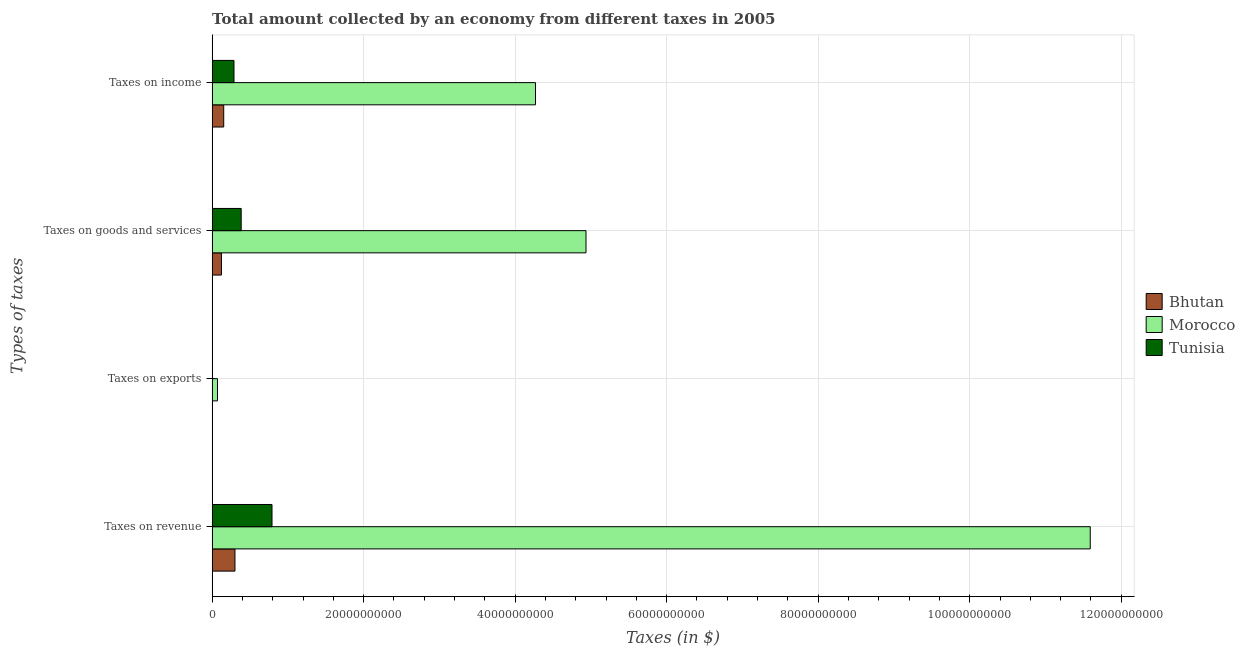How many different coloured bars are there?
Provide a succinct answer. 3. Are the number of bars per tick equal to the number of legend labels?
Your answer should be very brief. Yes. How many bars are there on the 2nd tick from the bottom?
Provide a short and direct response. 3. What is the label of the 1st group of bars from the top?
Provide a short and direct response. Taxes on income. What is the amount collected as tax on exports in Morocco?
Your answer should be compact. 7.10e+08. Across all countries, what is the maximum amount collected as tax on goods?
Keep it short and to the point. 4.94e+1. Across all countries, what is the minimum amount collected as tax on revenue?
Offer a terse response. 3.01e+09. In which country was the amount collected as tax on income maximum?
Make the answer very short. Morocco. In which country was the amount collected as tax on revenue minimum?
Offer a very short reply. Bhutan. What is the total amount collected as tax on income in the graph?
Keep it short and to the point. 4.71e+1. What is the difference between the amount collected as tax on goods in Tunisia and that in Morocco?
Offer a terse response. -4.55e+1. What is the difference between the amount collected as tax on revenue in Morocco and the amount collected as tax on goods in Bhutan?
Your response must be concise. 1.15e+11. What is the average amount collected as tax on goods per country?
Your answer should be compact. 1.81e+1. What is the difference between the amount collected as tax on exports and amount collected as tax on income in Bhutan?
Your response must be concise. -1.53e+09. In how many countries, is the amount collected as tax on exports greater than 28000000000 $?
Make the answer very short. 0. What is the ratio of the amount collected as tax on income in Morocco to that in Tunisia?
Give a very brief answer. 14.79. Is the amount collected as tax on goods in Bhutan less than that in Morocco?
Your answer should be very brief. Yes. What is the difference between the highest and the second highest amount collected as tax on revenue?
Provide a short and direct response. 1.08e+11. What is the difference between the highest and the lowest amount collected as tax on goods?
Your answer should be very brief. 4.81e+1. Is the sum of the amount collected as tax on income in Tunisia and Bhutan greater than the maximum amount collected as tax on revenue across all countries?
Make the answer very short. No. Is it the case that in every country, the sum of the amount collected as tax on exports and amount collected as tax on revenue is greater than the sum of amount collected as tax on goods and amount collected as tax on income?
Offer a very short reply. No. What does the 3rd bar from the top in Taxes on revenue represents?
Provide a succinct answer. Bhutan. What does the 2nd bar from the bottom in Taxes on exports represents?
Keep it short and to the point. Morocco. Are all the bars in the graph horizontal?
Your answer should be compact. Yes. How many countries are there in the graph?
Give a very brief answer. 3. What is the difference between two consecutive major ticks on the X-axis?
Offer a terse response. 2.00e+1. Where does the legend appear in the graph?
Provide a short and direct response. Center right. What is the title of the graph?
Provide a succinct answer. Total amount collected by an economy from different taxes in 2005. What is the label or title of the X-axis?
Provide a succinct answer. Taxes (in $). What is the label or title of the Y-axis?
Your answer should be compact. Types of taxes. What is the Taxes (in $) in Bhutan in Taxes on revenue?
Provide a succinct answer. 3.01e+09. What is the Taxes (in $) in Morocco in Taxes on revenue?
Offer a terse response. 1.16e+11. What is the Taxes (in $) of Tunisia in Taxes on revenue?
Your answer should be very brief. 7.90e+09. What is the Taxes (in $) of Bhutan in Taxes on exports?
Provide a short and direct response. 8.70e+05. What is the Taxes (in $) of Morocco in Taxes on exports?
Make the answer very short. 7.10e+08. What is the Taxes (in $) of Tunisia in Taxes on exports?
Your answer should be very brief. 7.40e+06. What is the Taxes (in $) in Bhutan in Taxes on goods and services?
Offer a terse response. 1.23e+09. What is the Taxes (in $) of Morocco in Taxes on goods and services?
Provide a succinct answer. 4.94e+1. What is the Taxes (in $) in Tunisia in Taxes on goods and services?
Your answer should be very brief. 3.84e+09. What is the Taxes (in $) in Bhutan in Taxes on income?
Your answer should be very brief. 1.53e+09. What is the Taxes (in $) in Morocco in Taxes on income?
Offer a terse response. 4.27e+1. What is the Taxes (in $) of Tunisia in Taxes on income?
Your response must be concise. 2.89e+09. Across all Types of taxes, what is the maximum Taxes (in $) of Bhutan?
Your answer should be very brief. 3.01e+09. Across all Types of taxes, what is the maximum Taxes (in $) of Morocco?
Give a very brief answer. 1.16e+11. Across all Types of taxes, what is the maximum Taxes (in $) in Tunisia?
Provide a succinct answer. 7.90e+09. Across all Types of taxes, what is the minimum Taxes (in $) of Bhutan?
Your response must be concise. 8.70e+05. Across all Types of taxes, what is the minimum Taxes (in $) in Morocco?
Your response must be concise. 7.10e+08. Across all Types of taxes, what is the minimum Taxes (in $) of Tunisia?
Your answer should be compact. 7.40e+06. What is the total Taxes (in $) in Bhutan in the graph?
Provide a succinct answer. 5.78e+09. What is the total Taxes (in $) in Morocco in the graph?
Ensure brevity in your answer.  2.09e+11. What is the total Taxes (in $) in Tunisia in the graph?
Make the answer very short. 1.46e+1. What is the difference between the Taxes (in $) of Bhutan in Taxes on revenue and that in Taxes on exports?
Give a very brief answer. 3.01e+09. What is the difference between the Taxes (in $) in Morocco in Taxes on revenue and that in Taxes on exports?
Your response must be concise. 1.15e+11. What is the difference between the Taxes (in $) of Tunisia in Taxes on revenue and that in Taxes on exports?
Give a very brief answer. 7.90e+09. What is the difference between the Taxes (in $) in Bhutan in Taxes on revenue and that in Taxes on goods and services?
Your answer should be very brief. 1.78e+09. What is the difference between the Taxes (in $) of Morocco in Taxes on revenue and that in Taxes on goods and services?
Provide a short and direct response. 6.66e+1. What is the difference between the Taxes (in $) in Tunisia in Taxes on revenue and that in Taxes on goods and services?
Provide a short and direct response. 4.07e+09. What is the difference between the Taxes (in $) in Bhutan in Taxes on revenue and that in Taxes on income?
Provide a short and direct response. 1.48e+09. What is the difference between the Taxes (in $) in Morocco in Taxes on revenue and that in Taxes on income?
Offer a very short reply. 7.32e+1. What is the difference between the Taxes (in $) of Tunisia in Taxes on revenue and that in Taxes on income?
Offer a terse response. 5.02e+09. What is the difference between the Taxes (in $) of Bhutan in Taxes on exports and that in Taxes on goods and services?
Offer a terse response. -1.23e+09. What is the difference between the Taxes (in $) in Morocco in Taxes on exports and that in Taxes on goods and services?
Provide a succinct answer. -4.86e+1. What is the difference between the Taxes (in $) in Tunisia in Taxes on exports and that in Taxes on goods and services?
Keep it short and to the point. -3.83e+09. What is the difference between the Taxes (in $) of Bhutan in Taxes on exports and that in Taxes on income?
Keep it short and to the point. -1.53e+09. What is the difference between the Taxes (in $) of Morocco in Taxes on exports and that in Taxes on income?
Offer a very short reply. -4.20e+1. What is the difference between the Taxes (in $) of Tunisia in Taxes on exports and that in Taxes on income?
Ensure brevity in your answer.  -2.88e+09. What is the difference between the Taxes (in $) in Bhutan in Taxes on goods and services and that in Taxes on income?
Offer a very short reply. -3.00e+08. What is the difference between the Taxes (in $) of Morocco in Taxes on goods and services and that in Taxes on income?
Offer a very short reply. 6.67e+09. What is the difference between the Taxes (in $) of Tunisia in Taxes on goods and services and that in Taxes on income?
Offer a very short reply. 9.51e+08. What is the difference between the Taxes (in $) in Bhutan in Taxes on revenue and the Taxes (in $) in Morocco in Taxes on exports?
Offer a very short reply. 2.30e+09. What is the difference between the Taxes (in $) of Bhutan in Taxes on revenue and the Taxes (in $) of Tunisia in Taxes on exports?
Provide a succinct answer. 3.01e+09. What is the difference between the Taxes (in $) in Morocco in Taxes on revenue and the Taxes (in $) in Tunisia in Taxes on exports?
Your answer should be compact. 1.16e+11. What is the difference between the Taxes (in $) of Bhutan in Taxes on revenue and the Taxes (in $) of Morocco in Taxes on goods and services?
Provide a short and direct response. -4.63e+1. What is the difference between the Taxes (in $) in Bhutan in Taxes on revenue and the Taxes (in $) in Tunisia in Taxes on goods and services?
Your answer should be compact. -8.23e+08. What is the difference between the Taxes (in $) of Morocco in Taxes on revenue and the Taxes (in $) of Tunisia in Taxes on goods and services?
Make the answer very short. 1.12e+11. What is the difference between the Taxes (in $) of Bhutan in Taxes on revenue and the Taxes (in $) of Morocco in Taxes on income?
Provide a short and direct response. -3.97e+1. What is the difference between the Taxes (in $) in Bhutan in Taxes on revenue and the Taxes (in $) in Tunisia in Taxes on income?
Provide a succinct answer. 1.28e+08. What is the difference between the Taxes (in $) in Morocco in Taxes on revenue and the Taxes (in $) in Tunisia in Taxes on income?
Ensure brevity in your answer.  1.13e+11. What is the difference between the Taxes (in $) of Bhutan in Taxes on exports and the Taxes (in $) of Morocco in Taxes on goods and services?
Offer a very short reply. -4.93e+1. What is the difference between the Taxes (in $) in Bhutan in Taxes on exports and the Taxes (in $) in Tunisia in Taxes on goods and services?
Keep it short and to the point. -3.84e+09. What is the difference between the Taxes (in $) of Morocco in Taxes on exports and the Taxes (in $) of Tunisia in Taxes on goods and services?
Keep it short and to the point. -3.13e+09. What is the difference between the Taxes (in $) of Bhutan in Taxes on exports and the Taxes (in $) of Morocco in Taxes on income?
Provide a succinct answer. -4.27e+1. What is the difference between the Taxes (in $) of Bhutan in Taxes on exports and the Taxes (in $) of Tunisia in Taxes on income?
Offer a very short reply. -2.89e+09. What is the difference between the Taxes (in $) of Morocco in Taxes on exports and the Taxes (in $) of Tunisia in Taxes on income?
Your response must be concise. -2.18e+09. What is the difference between the Taxes (in $) of Bhutan in Taxes on goods and services and the Taxes (in $) of Morocco in Taxes on income?
Make the answer very short. -4.15e+1. What is the difference between the Taxes (in $) of Bhutan in Taxes on goods and services and the Taxes (in $) of Tunisia in Taxes on income?
Provide a succinct answer. -1.66e+09. What is the difference between the Taxes (in $) of Morocco in Taxes on goods and services and the Taxes (in $) of Tunisia in Taxes on income?
Offer a very short reply. 4.65e+1. What is the average Taxes (in $) of Bhutan per Types of taxes?
Give a very brief answer. 1.44e+09. What is the average Taxes (in $) in Morocco per Types of taxes?
Provide a short and direct response. 5.22e+1. What is the average Taxes (in $) of Tunisia per Types of taxes?
Your response must be concise. 3.66e+09. What is the difference between the Taxes (in $) in Bhutan and Taxes (in $) in Morocco in Taxes on revenue?
Ensure brevity in your answer.  -1.13e+11. What is the difference between the Taxes (in $) of Bhutan and Taxes (in $) of Tunisia in Taxes on revenue?
Your answer should be compact. -4.89e+09. What is the difference between the Taxes (in $) of Morocco and Taxes (in $) of Tunisia in Taxes on revenue?
Offer a terse response. 1.08e+11. What is the difference between the Taxes (in $) in Bhutan and Taxes (in $) in Morocco in Taxes on exports?
Provide a short and direct response. -7.09e+08. What is the difference between the Taxes (in $) in Bhutan and Taxes (in $) in Tunisia in Taxes on exports?
Your response must be concise. -6.53e+06. What is the difference between the Taxes (in $) in Morocco and Taxes (in $) in Tunisia in Taxes on exports?
Your answer should be very brief. 7.02e+08. What is the difference between the Taxes (in $) in Bhutan and Taxes (in $) in Morocco in Taxes on goods and services?
Make the answer very short. -4.81e+1. What is the difference between the Taxes (in $) in Bhutan and Taxes (in $) in Tunisia in Taxes on goods and services?
Your response must be concise. -2.61e+09. What is the difference between the Taxes (in $) in Morocco and Taxes (in $) in Tunisia in Taxes on goods and services?
Make the answer very short. 4.55e+1. What is the difference between the Taxes (in $) of Bhutan and Taxes (in $) of Morocco in Taxes on income?
Make the answer very short. -4.12e+1. What is the difference between the Taxes (in $) in Bhutan and Taxes (in $) in Tunisia in Taxes on income?
Your answer should be very brief. -1.36e+09. What is the difference between the Taxes (in $) of Morocco and Taxes (in $) of Tunisia in Taxes on income?
Give a very brief answer. 3.98e+1. What is the ratio of the Taxes (in $) of Bhutan in Taxes on revenue to that in Taxes on exports?
Offer a very short reply. 3464.51. What is the ratio of the Taxes (in $) in Morocco in Taxes on revenue to that in Taxes on exports?
Offer a terse response. 163.28. What is the ratio of the Taxes (in $) of Tunisia in Taxes on revenue to that in Taxes on exports?
Provide a succinct answer. 1068.14. What is the ratio of the Taxes (in $) in Bhutan in Taxes on revenue to that in Taxes on goods and services?
Your answer should be compact. 2.45. What is the ratio of the Taxes (in $) in Morocco in Taxes on revenue to that in Taxes on goods and services?
Offer a very short reply. 2.35. What is the ratio of the Taxes (in $) in Tunisia in Taxes on revenue to that in Taxes on goods and services?
Make the answer very short. 2.06. What is the ratio of the Taxes (in $) in Bhutan in Taxes on revenue to that in Taxes on income?
Your answer should be compact. 1.97. What is the ratio of the Taxes (in $) in Morocco in Taxes on revenue to that in Taxes on income?
Offer a terse response. 2.72. What is the ratio of the Taxes (in $) of Tunisia in Taxes on revenue to that in Taxes on income?
Offer a very short reply. 2.74. What is the ratio of the Taxes (in $) in Bhutan in Taxes on exports to that in Taxes on goods and services?
Give a very brief answer. 0. What is the ratio of the Taxes (in $) in Morocco in Taxes on exports to that in Taxes on goods and services?
Provide a short and direct response. 0.01. What is the ratio of the Taxes (in $) of Tunisia in Taxes on exports to that in Taxes on goods and services?
Make the answer very short. 0. What is the ratio of the Taxes (in $) in Bhutan in Taxes on exports to that in Taxes on income?
Offer a very short reply. 0. What is the ratio of the Taxes (in $) of Morocco in Taxes on exports to that in Taxes on income?
Ensure brevity in your answer.  0.02. What is the ratio of the Taxes (in $) in Tunisia in Taxes on exports to that in Taxes on income?
Your answer should be very brief. 0. What is the ratio of the Taxes (in $) in Bhutan in Taxes on goods and services to that in Taxes on income?
Provide a succinct answer. 0.8. What is the ratio of the Taxes (in $) in Morocco in Taxes on goods and services to that in Taxes on income?
Your response must be concise. 1.16. What is the ratio of the Taxes (in $) in Tunisia in Taxes on goods and services to that in Taxes on income?
Make the answer very short. 1.33. What is the difference between the highest and the second highest Taxes (in $) of Bhutan?
Your answer should be very brief. 1.48e+09. What is the difference between the highest and the second highest Taxes (in $) of Morocco?
Provide a short and direct response. 6.66e+1. What is the difference between the highest and the second highest Taxes (in $) in Tunisia?
Provide a succinct answer. 4.07e+09. What is the difference between the highest and the lowest Taxes (in $) in Bhutan?
Offer a very short reply. 3.01e+09. What is the difference between the highest and the lowest Taxes (in $) in Morocco?
Give a very brief answer. 1.15e+11. What is the difference between the highest and the lowest Taxes (in $) of Tunisia?
Offer a terse response. 7.90e+09. 